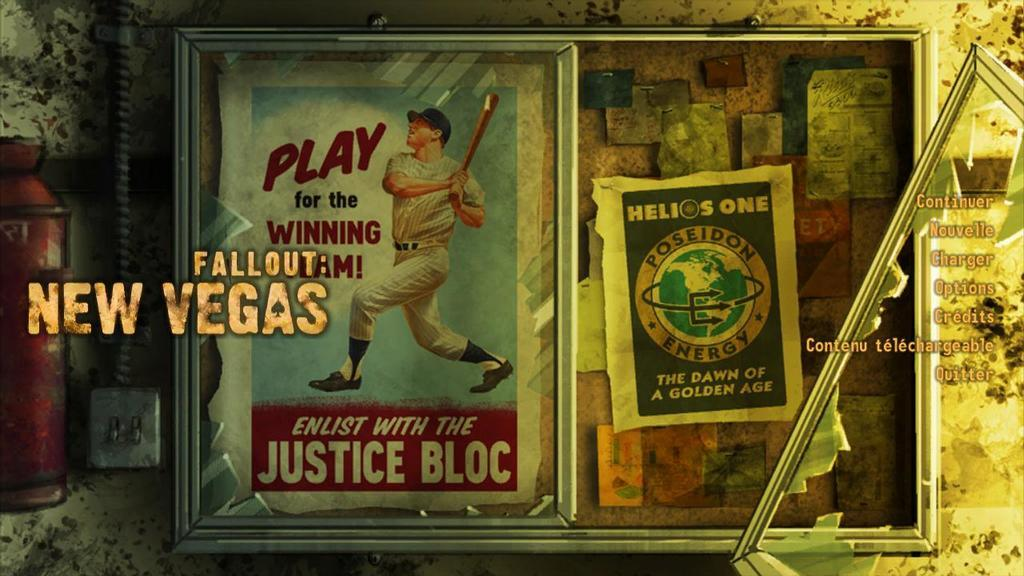<image>
Give a short and clear explanation of the subsequent image. A framed poster says that we should enlist with the Justice Bloc. 